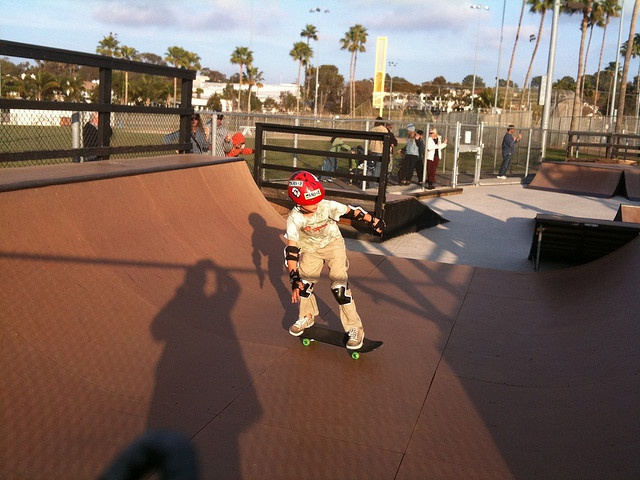Describe the objects in this image and their specific colors. I can see people in lightblue, tan, black, and beige tones, skateboard in lightblue, black, beige, and maroon tones, people in lightblue, maroon, ivory, gray, and black tones, people in lightblue, black, gray, and maroon tones, and people in lightblue, gray, and black tones in this image. 